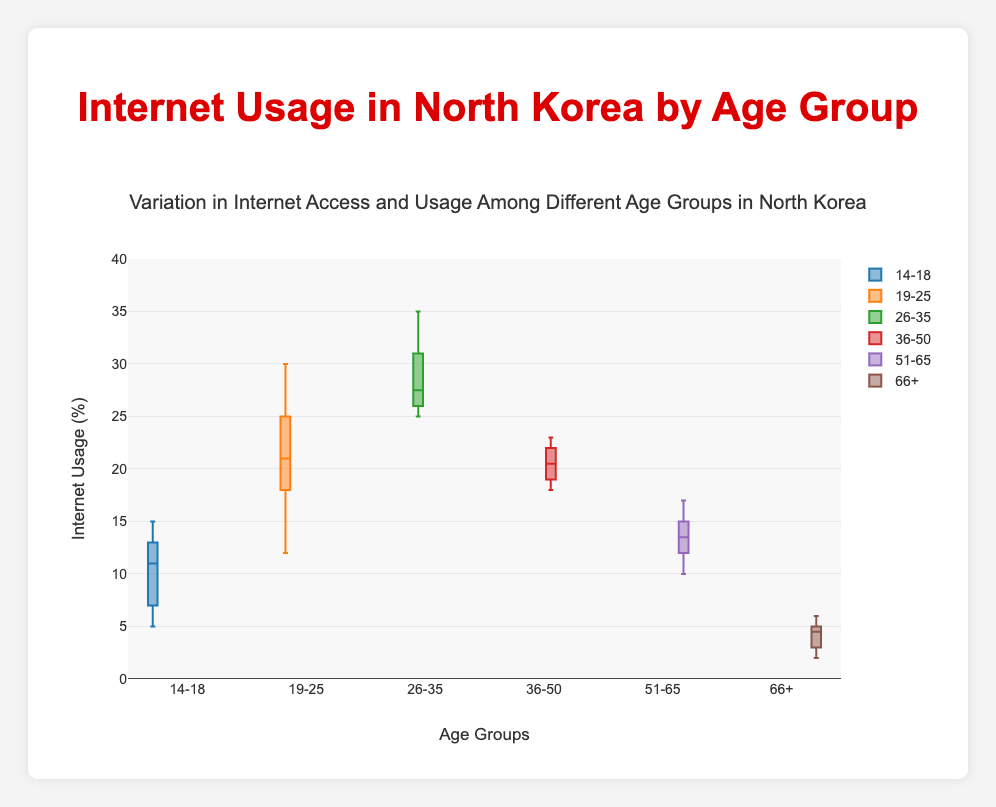What's the title of the figure? The title is usually located at the top center of the figure.
Answer: Variation in Internet Access and Usage Among Different Age Groups in North Korea What do the colors in the box plot represent? Each color represents a different age group. For instance, blue represents the 14-18 age group, orange represents the 19-25 age group, and so on.
Answer: Different age groups Which age group has the smallest variation in internet usage? The 66+ age group has the smallest variation because the box and whiskers are the shortest among all groups.
Answer: 66+ What is the highest internet usage percentage in the 19-25 age group? Look at the top whisker of the box plot for the 19-25 age group to determine the maximum value.
Answer: 30% Which age group shows the highest median internet usage? The median is represented by the line inside the box. The 26-35 age group has the highest median value.
Answer: 26-35 How does the internet usage of the 51-65 age group compare to that of the 14-18 age group in terms of their maximum values? Compare the top whiskers of the box plots for both age groups. The maximum value for 51-65 is 17%, while for 14-18, it's 15%.
Answer: 51-65 has a higher maximum What's the median value of internet usage in the 26-35 age group? The median is the line inside the box. For the 26-35 age group, the median value is approximately 27%.
Answer: 27% What is the interquartile range (IQR) for the 36-50 age group? The IQR is the range between the first quartile (bottom edge of the box) and the third quartile (top edge). For 36-50, it's approximately between 19% and 22%.
Answer: 3% How does the distribution of internet usage for the 14-18 age group compare to the 66+ age group in terms of range? The range is the difference between the maximum and minimum values. For 14-18, the range is 15% - 5% = 10%. For 66+, the range is 6% - 2% = 4%.
Answer: 14-18 has a larger range 